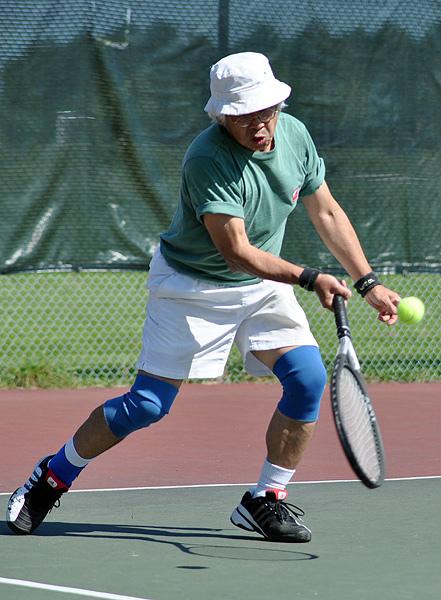Which hand holds a racket?
Write a very short answer. Right. Can the player's shadow be seen?
Keep it brief. Yes. What do you call the blue thing covering the knee?
Keep it brief. Ace bandages. 